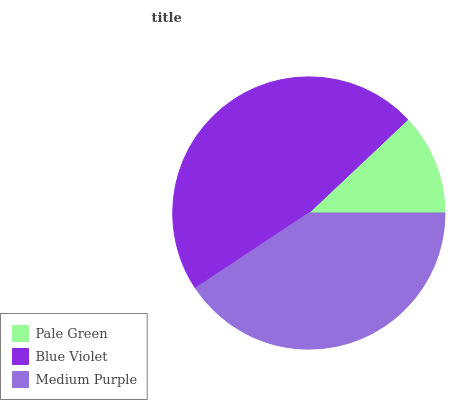Is Pale Green the minimum?
Answer yes or no. Yes. Is Blue Violet the maximum?
Answer yes or no. Yes. Is Medium Purple the minimum?
Answer yes or no. No. Is Medium Purple the maximum?
Answer yes or no. No. Is Blue Violet greater than Medium Purple?
Answer yes or no. Yes. Is Medium Purple less than Blue Violet?
Answer yes or no. Yes. Is Medium Purple greater than Blue Violet?
Answer yes or no. No. Is Blue Violet less than Medium Purple?
Answer yes or no. No. Is Medium Purple the high median?
Answer yes or no. Yes. Is Medium Purple the low median?
Answer yes or no. Yes. Is Blue Violet the high median?
Answer yes or no. No. Is Blue Violet the low median?
Answer yes or no. No. 